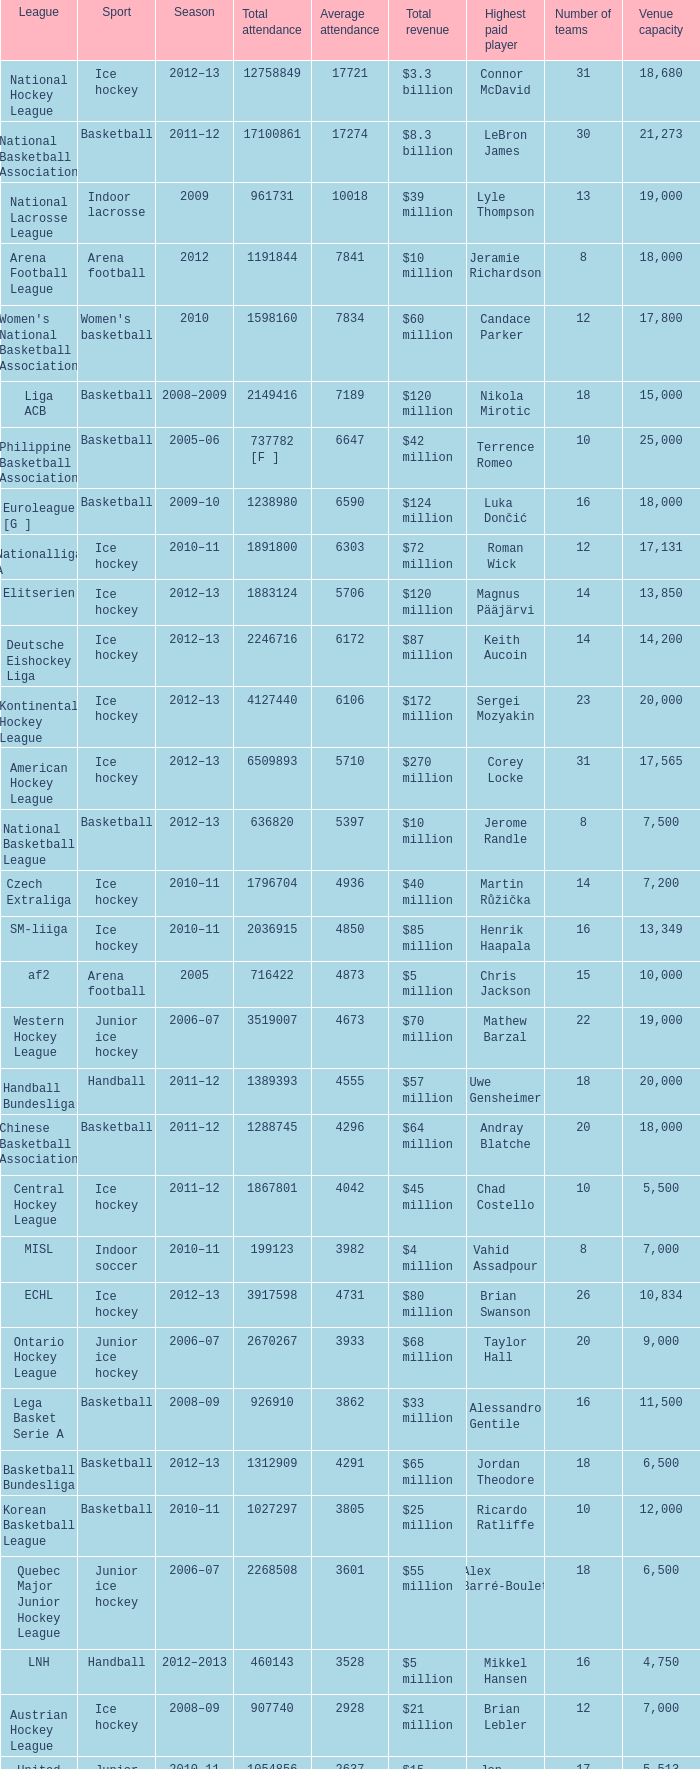What's the total attendance in rink hockey when the average attendance was smaller than 4850? 115000.0. Could you parse the entire table as a dict? {'header': ['League', 'Sport', 'Season', 'Total attendance', 'Average attendance', 'Total revenue', 'Highest paid player', 'Number of teams', 'Venue capacity'], 'rows': [['National Hockey League', 'Ice hockey', '2012–13', '12758849', '17721', '$3.3 billion', 'Connor McDavid', '31', '18,680'], ['National Basketball Association', 'Basketball', '2011–12', '17100861', '17274', '$8.3 billion', 'LeBron James', '30', '21,273'], ['National Lacrosse League', 'Indoor lacrosse', '2009', '961731', '10018', '$39 million', 'Lyle Thompson', '13', '19,000'], ['Arena Football League', 'Arena football', '2012', '1191844', '7841', '$10 million', 'Jeramie Richardson', '8', '18,000'], ["Women's National Basketball Association", "Women's basketball", '2010', '1598160', '7834', '$60 million', 'Candace Parker', '12', '17,800'], ['Liga ACB', 'Basketball', '2008–2009', '2149416', '7189', '$120 million', 'Nikola Mirotic', '18', '15,000'], ['Philippine Basketball Association', 'Basketball', '2005–06', '737782 [F ]', '6647', '$42 million', 'Terrence Romeo', '10', '25,000'], ['Euroleague [G ]', 'Basketball', '2009–10', '1238980', '6590', '$124 million', 'Luka Dončić', '16', '18,000'], ['Nationalliga A', 'Ice hockey', '2010–11', '1891800', '6303', '$72 million', 'Roman Wick', '12', '17,131'], ['Elitserien', 'Ice hockey', '2012–13', '1883124', '5706', '$120 million', 'Magnus Pääjärvi', '14', '13,850'], ['Deutsche Eishockey Liga', 'Ice hockey', '2012–13', '2246716', '6172', '$87 million', 'Keith Aucoin', '14', '14,200'], ['Kontinental Hockey League', 'Ice hockey', '2012–13', '4127440', '6106', '$172 million', 'Sergei Mozyakin', '23', '20,000'], ['American Hockey League', 'Ice hockey', '2012–13', '6509893', '5710', '$270 million', 'Corey Locke', '31', '17,565'], ['National Basketball League', 'Basketball', '2012–13', '636820', '5397', '$10 million', 'Jerome Randle', '8', '7,500'], ['Czech Extraliga', 'Ice hockey', '2010–11', '1796704', '4936', '$40 million', 'Martin Růžička', '14', '7,200'], ['SM-liiga', 'Ice hockey', '2010–11', '2036915', '4850', '$85 million', 'Henrik Haapala', '16', '13,349'], ['af2', 'Arena football', '2005', '716422', '4873', '$5 million', 'Chris Jackson', '15', '10,000'], ['Western Hockey League', 'Junior ice hockey', '2006–07', '3519007', '4673', '$70 million', 'Mathew Barzal', '22', '19,000'], ['Handball Bundesliga', 'Handball', '2011–12', '1389393', '4555', '$57 million', 'Uwe Gensheimer', '18', '20,000'], ['Chinese Basketball Association', 'Basketball', '2011–12', '1288745', '4296', '$64 million', 'Andray Blatche', '20', '18,000'], ['Central Hockey League', 'Ice hockey', '2011–12', '1867801', '4042', '$45 million', 'Chad Costello', '10', '5,500'], ['MISL', 'Indoor soccer', '2010–11', '199123', '3982', '$4 million', 'Vahid Assadpour', '8', '7,000'], ['ECHL', 'Ice hockey', '2012–13', '3917598', '4731', '$80 million', 'Brian Swanson', '26', '10,834'], ['Ontario Hockey League', 'Junior ice hockey', '2006–07', '2670267', '3933', '$68 million', 'Taylor Hall', '20', '9,000'], ['Lega Basket Serie A', 'Basketball', '2008–09', '926910', '3862', '$33 million', 'Alessandro Gentile', '16', '11,500'], ['Basketball Bundesliga', 'Basketball', '2012–13', '1312909', '4291', '$65 million', 'Jordan Theodore', '18', '6,500'], ['Korean Basketball League', 'Basketball', '2010–11', '1027297', '3805', '$25 million', 'Ricardo Ratliffe', '10', '12,000'], ['Quebec Major Junior Hockey League', 'Junior ice hockey', '2006–07', '2268508', '3601', '$55 million', 'Alex Barré-Boulet', '18', '6,500'], ['LNH', 'Handball', '2012–2013', '460143', '3528', '$5 million', 'Mikkel Hansen', '16', '4,750'], ['Austrian Hockey League', 'Ice hockey', '2008–09', '907740', '2928', '$21 million', 'Brian Lebler', '12', '7,000'], ['United States Hockey League', 'Junior ice hockey', '2010–11', '1054856', '2637', '$15 million', 'Jon Gillies', '17', '5,513'], ['Southern Professional Hockey League', 'Ice hockey', '2011–12', '704664', '2796', '$5 million', 'Ryan de Melo', '10', '8,000'], ['Slovak Extraliga', 'Ice hockey', '2004–05', '766816', '2840', '$19 million', 'Lubomir Vaic', '12', '8,000'], ['Russian Basketball Super League', 'Basketball', '2010–11', '385702', '2401', '$8 million', 'Artūrs Kurucs', '10', '6,000'], ['Lega Pallavolo Serie A', 'Volleyball', '2005–06', '469799', '2512', '$12 million', 'Ivan Zaytsev', '14', '3,184'], ['HockeyAllsvenskan', 'Ice hockey', '2012–13', '1174766', '3227', '$47 million', 'Andreas Johnson', '14', '12,044'], ['Elite Ice Hockey League', 'Ice Hockey', '2009–10', '743040', '2322', '$13 million', "Ben O'Connor", '11', '8,500'], ['Oddset Ligaen', 'Ice hockey', '2007–08', '407972', '1534', '$6 million', 'Nicklas Carlsen', '10', '3,288'], ['UPC Ligaen', 'Ice hockey', '2005–06', '329768', '1335', '$4 million', 'Niklas Andersen', '10', '4,000'], ['North American Hockey League', 'Junior ice hockey', '2010–11', '957323', '1269', '$8 million', 'Alec Hajdukovich', '24', '9,595'], ['Pro A Volleyball', 'Volleyball', '2005–06', '213678', '1174', '$3 million', 'Earvin Ngapeth', '14', '6,300'], ['Italian Rink Hockey League', 'Rink hockey', '2007–08', '115000', '632', '$2 million', 'João Rodrigues', '10', '4,000'], ['Minor Hockey League', 'Ice Hockey', '2012–13', '479003', '467', '$1 million', 'Michael Kramer', '8', '6,000'], ['Major Hockey League', 'Ice Hockey', '2012–13', '1356319', '1932', '$14 million', 'Alexei Kudashov', '14', '5,000'], ['VTB United League', 'Basketball', '2012–13', '572747', '2627', '$20 million', 'Kyle Hines', '13', '13,000'], ['Norwegian Premier League', "Women's handball", '2005–06', '58958', '447', '$1.2 million', 'Katrine Lunde', '12', '7,000'], ['Polska Liga Koszykówki', 'Basketball', '2011–12', '535559', '1940', '$14 million', 'Walter Hodge', '16', '7,200']]} 